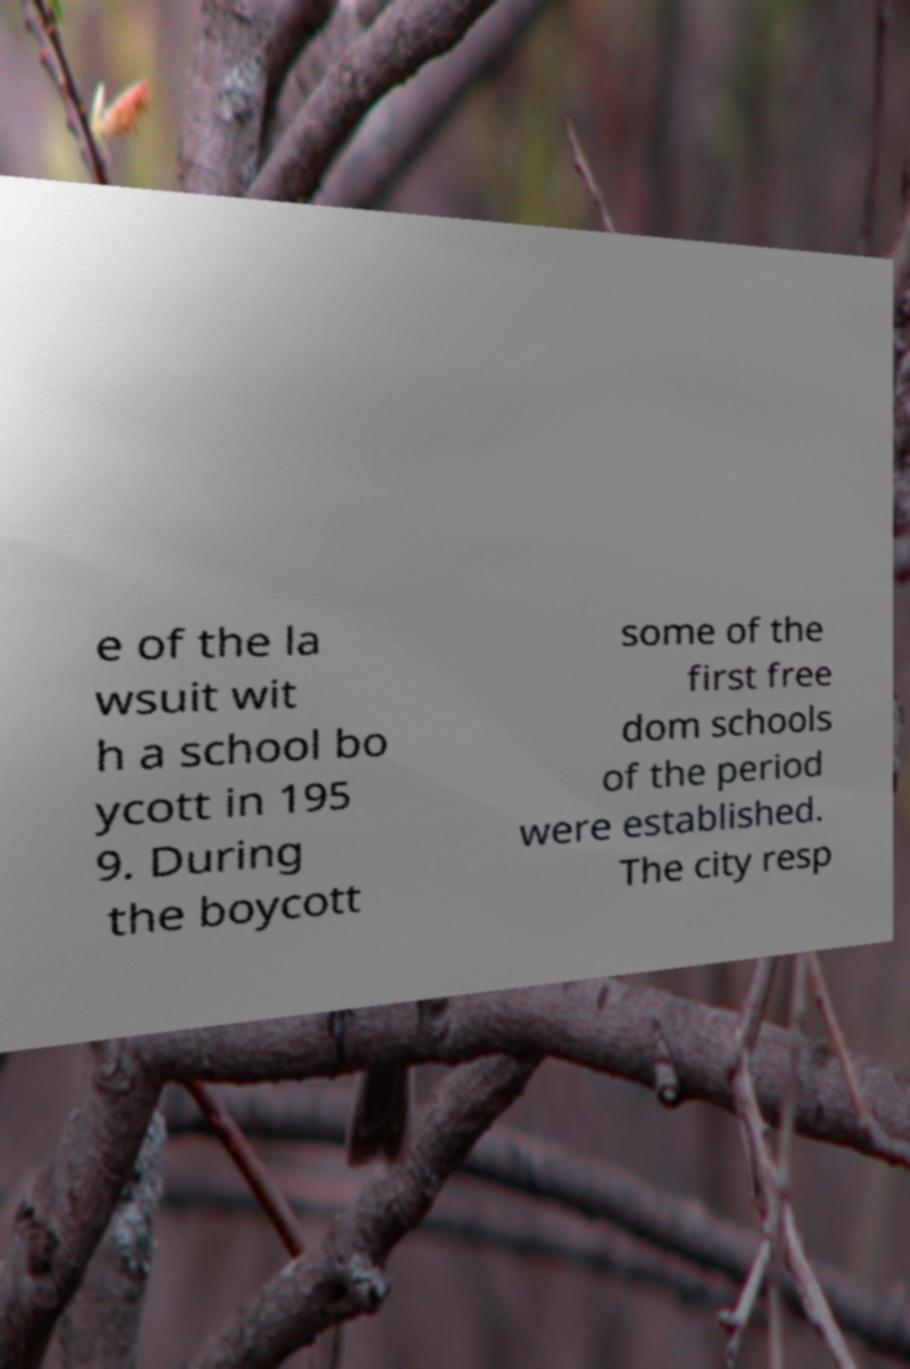Please read and relay the text visible in this image. What does it say? e of the la wsuit wit h a school bo ycott in 195 9. During the boycott some of the first free dom schools of the period were established. The city resp 